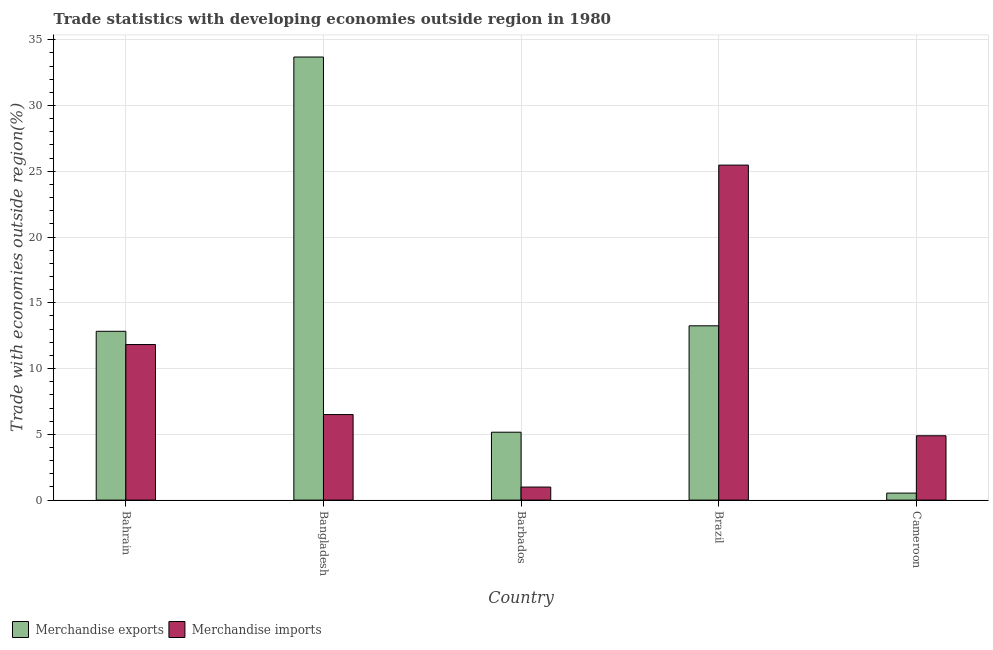How many groups of bars are there?
Ensure brevity in your answer.  5. What is the label of the 1st group of bars from the left?
Your answer should be very brief. Bahrain. In how many cases, is the number of bars for a given country not equal to the number of legend labels?
Ensure brevity in your answer.  0. What is the merchandise exports in Barbados?
Make the answer very short. 5.16. Across all countries, what is the maximum merchandise exports?
Your answer should be compact. 33.69. Across all countries, what is the minimum merchandise exports?
Give a very brief answer. 0.53. In which country was the merchandise imports maximum?
Your answer should be compact. Brazil. In which country was the merchandise exports minimum?
Your answer should be very brief. Cameroon. What is the total merchandise imports in the graph?
Give a very brief answer. 49.68. What is the difference between the merchandise imports in Barbados and that in Cameroon?
Your answer should be very brief. -3.9. What is the difference between the merchandise imports in Bahrain and the merchandise exports in Cameroon?
Offer a terse response. 11.29. What is the average merchandise imports per country?
Offer a very short reply. 9.94. What is the difference between the merchandise exports and merchandise imports in Cameroon?
Offer a very short reply. -4.36. What is the ratio of the merchandise imports in Bangladesh to that in Cameroon?
Make the answer very short. 1.33. Is the difference between the merchandise exports in Bahrain and Cameroon greater than the difference between the merchandise imports in Bahrain and Cameroon?
Offer a terse response. Yes. What is the difference between the highest and the second highest merchandise imports?
Your response must be concise. 13.64. What is the difference between the highest and the lowest merchandise exports?
Your answer should be compact. 33.15. What does the 2nd bar from the right in Cameroon represents?
Provide a short and direct response. Merchandise exports. Are all the bars in the graph horizontal?
Provide a succinct answer. No. How many countries are there in the graph?
Your answer should be very brief. 5. What is the difference between two consecutive major ticks on the Y-axis?
Keep it short and to the point. 5. Does the graph contain grids?
Your response must be concise. Yes. How many legend labels are there?
Your answer should be very brief. 2. What is the title of the graph?
Offer a very short reply. Trade statistics with developing economies outside region in 1980. Does "International Tourists" appear as one of the legend labels in the graph?
Your answer should be very brief. No. What is the label or title of the X-axis?
Offer a terse response. Country. What is the label or title of the Y-axis?
Provide a succinct answer. Trade with economies outside region(%). What is the Trade with economies outside region(%) in Merchandise exports in Bahrain?
Offer a terse response. 12.83. What is the Trade with economies outside region(%) of Merchandise imports in Bahrain?
Your answer should be very brief. 11.83. What is the Trade with economies outside region(%) in Merchandise exports in Bangladesh?
Provide a succinct answer. 33.69. What is the Trade with economies outside region(%) in Merchandise imports in Bangladesh?
Make the answer very short. 6.5. What is the Trade with economies outside region(%) in Merchandise exports in Barbados?
Make the answer very short. 5.16. What is the Trade with economies outside region(%) in Merchandise imports in Barbados?
Ensure brevity in your answer.  0.99. What is the Trade with economies outside region(%) in Merchandise exports in Brazil?
Provide a succinct answer. 13.25. What is the Trade with economies outside region(%) in Merchandise imports in Brazil?
Your response must be concise. 25.47. What is the Trade with economies outside region(%) of Merchandise exports in Cameroon?
Provide a succinct answer. 0.53. What is the Trade with economies outside region(%) of Merchandise imports in Cameroon?
Offer a terse response. 4.89. Across all countries, what is the maximum Trade with economies outside region(%) in Merchandise exports?
Your answer should be compact. 33.69. Across all countries, what is the maximum Trade with economies outside region(%) of Merchandise imports?
Offer a terse response. 25.47. Across all countries, what is the minimum Trade with economies outside region(%) of Merchandise exports?
Keep it short and to the point. 0.53. Across all countries, what is the minimum Trade with economies outside region(%) of Merchandise imports?
Your response must be concise. 0.99. What is the total Trade with economies outside region(%) of Merchandise exports in the graph?
Your answer should be very brief. 65.46. What is the total Trade with economies outside region(%) of Merchandise imports in the graph?
Provide a short and direct response. 49.68. What is the difference between the Trade with economies outside region(%) in Merchandise exports in Bahrain and that in Bangladesh?
Your answer should be compact. -20.85. What is the difference between the Trade with economies outside region(%) in Merchandise imports in Bahrain and that in Bangladesh?
Your response must be concise. 5.32. What is the difference between the Trade with economies outside region(%) of Merchandise exports in Bahrain and that in Barbados?
Your response must be concise. 7.67. What is the difference between the Trade with economies outside region(%) in Merchandise imports in Bahrain and that in Barbados?
Your answer should be compact. 10.84. What is the difference between the Trade with economies outside region(%) of Merchandise exports in Bahrain and that in Brazil?
Make the answer very short. -0.42. What is the difference between the Trade with economies outside region(%) in Merchandise imports in Bahrain and that in Brazil?
Provide a succinct answer. -13.64. What is the difference between the Trade with economies outside region(%) of Merchandise exports in Bahrain and that in Cameroon?
Your response must be concise. 12.3. What is the difference between the Trade with economies outside region(%) in Merchandise imports in Bahrain and that in Cameroon?
Provide a succinct answer. 6.94. What is the difference between the Trade with economies outside region(%) of Merchandise exports in Bangladesh and that in Barbados?
Your response must be concise. 28.52. What is the difference between the Trade with economies outside region(%) in Merchandise imports in Bangladesh and that in Barbados?
Keep it short and to the point. 5.51. What is the difference between the Trade with economies outside region(%) in Merchandise exports in Bangladesh and that in Brazil?
Keep it short and to the point. 20.43. What is the difference between the Trade with economies outside region(%) in Merchandise imports in Bangladesh and that in Brazil?
Your response must be concise. -18.97. What is the difference between the Trade with economies outside region(%) of Merchandise exports in Bangladesh and that in Cameroon?
Provide a short and direct response. 33.15. What is the difference between the Trade with economies outside region(%) of Merchandise imports in Bangladesh and that in Cameroon?
Ensure brevity in your answer.  1.61. What is the difference between the Trade with economies outside region(%) of Merchandise exports in Barbados and that in Brazil?
Your answer should be very brief. -8.09. What is the difference between the Trade with economies outside region(%) in Merchandise imports in Barbados and that in Brazil?
Your response must be concise. -24.48. What is the difference between the Trade with economies outside region(%) in Merchandise exports in Barbados and that in Cameroon?
Give a very brief answer. 4.63. What is the difference between the Trade with economies outside region(%) of Merchandise imports in Barbados and that in Cameroon?
Provide a succinct answer. -3.9. What is the difference between the Trade with economies outside region(%) in Merchandise exports in Brazil and that in Cameroon?
Your answer should be compact. 12.72. What is the difference between the Trade with economies outside region(%) in Merchandise imports in Brazil and that in Cameroon?
Your answer should be compact. 20.58. What is the difference between the Trade with economies outside region(%) of Merchandise exports in Bahrain and the Trade with economies outside region(%) of Merchandise imports in Bangladesh?
Offer a very short reply. 6.33. What is the difference between the Trade with economies outside region(%) of Merchandise exports in Bahrain and the Trade with economies outside region(%) of Merchandise imports in Barbados?
Offer a terse response. 11.84. What is the difference between the Trade with economies outside region(%) in Merchandise exports in Bahrain and the Trade with economies outside region(%) in Merchandise imports in Brazil?
Make the answer very short. -12.63. What is the difference between the Trade with economies outside region(%) in Merchandise exports in Bahrain and the Trade with economies outside region(%) in Merchandise imports in Cameroon?
Offer a terse response. 7.94. What is the difference between the Trade with economies outside region(%) in Merchandise exports in Bangladesh and the Trade with economies outside region(%) in Merchandise imports in Barbados?
Make the answer very short. 32.69. What is the difference between the Trade with economies outside region(%) in Merchandise exports in Bangladesh and the Trade with economies outside region(%) in Merchandise imports in Brazil?
Provide a succinct answer. 8.22. What is the difference between the Trade with economies outside region(%) in Merchandise exports in Bangladesh and the Trade with economies outside region(%) in Merchandise imports in Cameroon?
Offer a terse response. 28.79. What is the difference between the Trade with economies outside region(%) in Merchandise exports in Barbados and the Trade with economies outside region(%) in Merchandise imports in Brazil?
Provide a short and direct response. -20.31. What is the difference between the Trade with economies outside region(%) in Merchandise exports in Barbados and the Trade with economies outside region(%) in Merchandise imports in Cameroon?
Your answer should be compact. 0.27. What is the difference between the Trade with economies outside region(%) of Merchandise exports in Brazil and the Trade with economies outside region(%) of Merchandise imports in Cameroon?
Keep it short and to the point. 8.36. What is the average Trade with economies outside region(%) of Merchandise exports per country?
Offer a very short reply. 13.09. What is the average Trade with economies outside region(%) in Merchandise imports per country?
Ensure brevity in your answer.  9.94. What is the difference between the Trade with economies outside region(%) in Merchandise exports and Trade with economies outside region(%) in Merchandise imports in Bahrain?
Provide a succinct answer. 1.01. What is the difference between the Trade with economies outside region(%) of Merchandise exports and Trade with economies outside region(%) of Merchandise imports in Bangladesh?
Offer a very short reply. 27.18. What is the difference between the Trade with economies outside region(%) of Merchandise exports and Trade with economies outside region(%) of Merchandise imports in Barbados?
Provide a succinct answer. 4.17. What is the difference between the Trade with economies outside region(%) in Merchandise exports and Trade with economies outside region(%) in Merchandise imports in Brazil?
Your response must be concise. -12.22. What is the difference between the Trade with economies outside region(%) of Merchandise exports and Trade with economies outside region(%) of Merchandise imports in Cameroon?
Keep it short and to the point. -4.36. What is the ratio of the Trade with economies outside region(%) in Merchandise exports in Bahrain to that in Bangladesh?
Your answer should be very brief. 0.38. What is the ratio of the Trade with economies outside region(%) in Merchandise imports in Bahrain to that in Bangladesh?
Give a very brief answer. 1.82. What is the ratio of the Trade with economies outside region(%) of Merchandise exports in Bahrain to that in Barbados?
Keep it short and to the point. 2.49. What is the ratio of the Trade with economies outside region(%) of Merchandise imports in Bahrain to that in Barbados?
Your response must be concise. 11.93. What is the ratio of the Trade with economies outside region(%) in Merchandise exports in Bahrain to that in Brazil?
Offer a terse response. 0.97. What is the ratio of the Trade with economies outside region(%) in Merchandise imports in Bahrain to that in Brazil?
Offer a very short reply. 0.46. What is the ratio of the Trade with economies outside region(%) of Merchandise exports in Bahrain to that in Cameroon?
Make the answer very short. 24.12. What is the ratio of the Trade with economies outside region(%) in Merchandise imports in Bahrain to that in Cameroon?
Offer a very short reply. 2.42. What is the ratio of the Trade with economies outside region(%) in Merchandise exports in Bangladesh to that in Barbados?
Provide a succinct answer. 6.53. What is the ratio of the Trade with economies outside region(%) in Merchandise imports in Bangladesh to that in Barbados?
Ensure brevity in your answer.  6.56. What is the ratio of the Trade with economies outside region(%) of Merchandise exports in Bangladesh to that in Brazil?
Provide a succinct answer. 2.54. What is the ratio of the Trade with economies outside region(%) of Merchandise imports in Bangladesh to that in Brazil?
Provide a succinct answer. 0.26. What is the ratio of the Trade with economies outside region(%) of Merchandise exports in Bangladesh to that in Cameroon?
Ensure brevity in your answer.  63.3. What is the ratio of the Trade with economies outside region(%) in Merchandise imports in Bangladesh to that in Cameroon?
Give a very brief answer. 1.33. What is the ratio of the Trade with economies outside region(%) in Merchandise exports in Barbados to that in Brazil?
Offer a very short reply. 0.39. What is the ratio of the Trade with economies outside region(%) in Merchandise imports in Barbados to that in Brazil?
Your answer should be very brief. 0.04. What is the ratio of the Trade with economies outside region(%) of Merchandise exports in Barbados to that in Cameroon?
Provide a succinct answer. 9.7. What is the ratio of the Trade with economies outside region(%) in Merchandise imports in Barbados to that in Cameroon?
Offer a terse response. 0.2. What is the ratio of the Trade with economies outside region(%) in Merchandise exports in Brazil to that in Cameroon?
Your answer should be compact. 24.9. What is the ratio of the Trade with economies outside region(%) in Merchandise imports in Brazil to that in Cameroon?
Offer a terse response. 5.21. What is the difference between the highest and the second highest Trade with economies outside region(%) of Merchandise exports?
Give a very brief answer. 20.43. What is the difference between the highest and the second highest Trade with economies outside region(%) in Merchandise imports?
Provide a succinct answer. 13.64. What is the difference between the highest and the lowest Trade with economies outside region(%) in Merchandise exports?
Keep it short and to the point. 33.15. What is the difference between the highest and the lowest Trade with economies outside region(%) in Merchandise imports?
Provide a short and direct response. 24.48. 